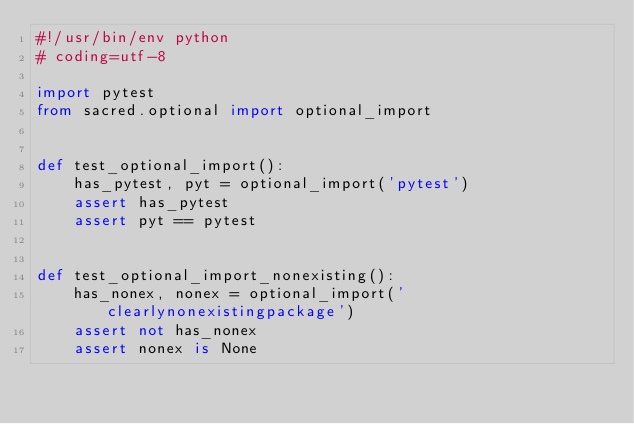<code> <loc_0><loc_0><loc_500><loc_500><_Python_>#!/usr/bin/env python
# coding=utf-8

import pytest
from sacred.optional import optional_import


def test_optional_import():
    has_pytest, pyt = optional_import('pytest')
    assert has_pytest
    assert pyt == pytest


def test_optional_import_nonexisting():
    has_nonex, nonex = optional_import('clearlynonexistingpackage')
    assert not has_nonex
    assert nonex is None
</code> 